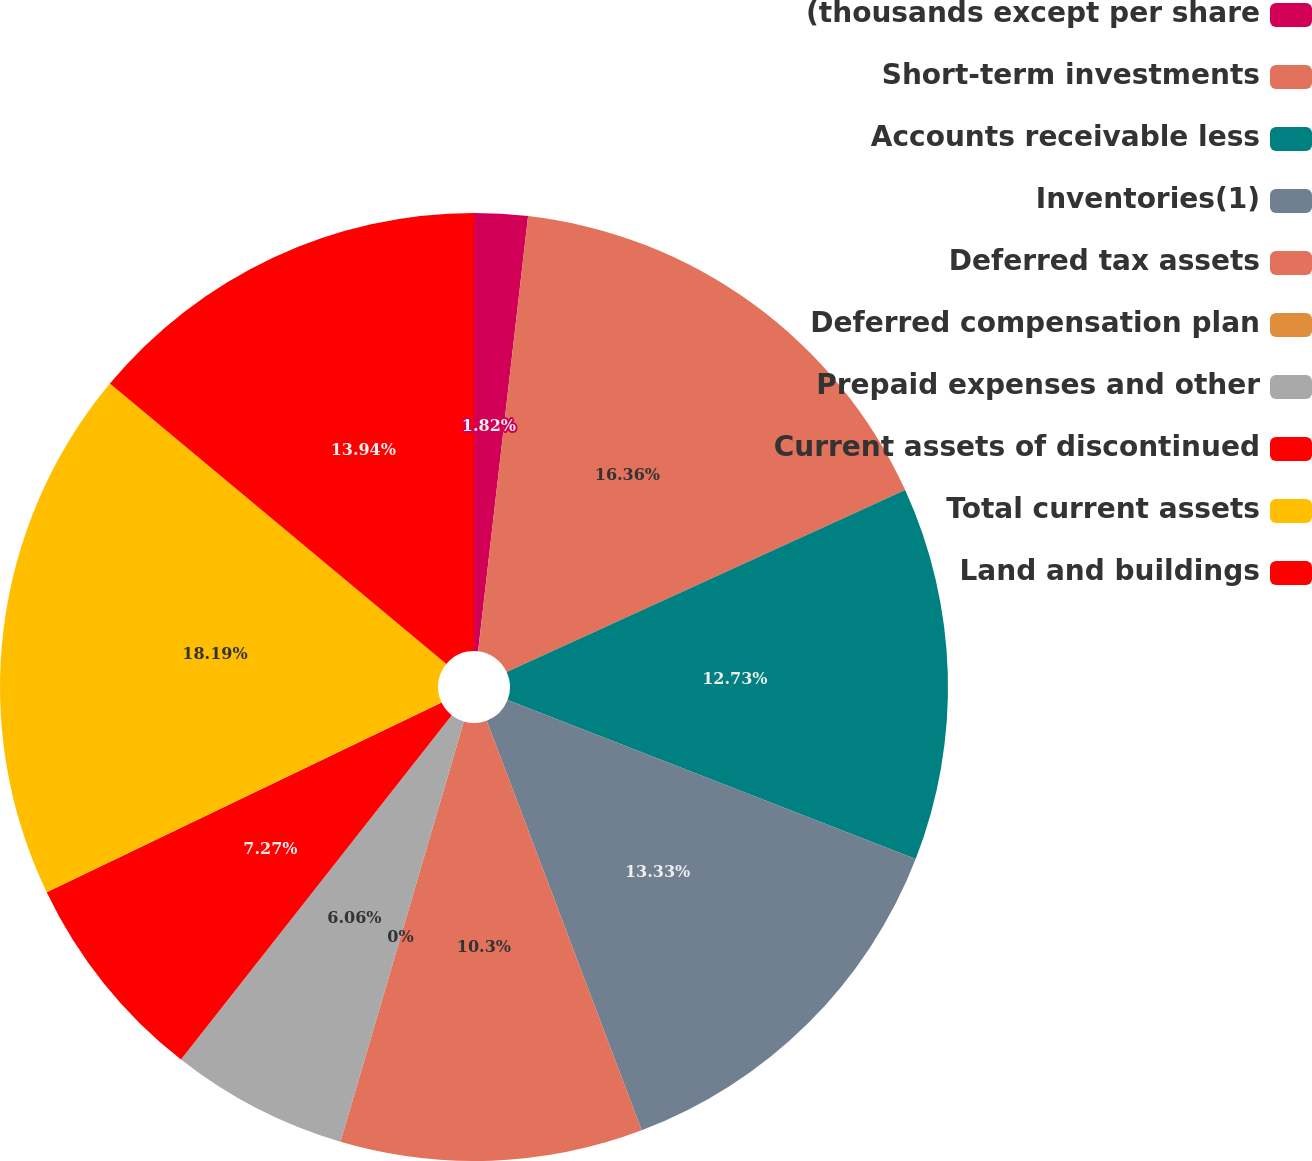<chart> <loc_0><loc_0><loc_500><loc_500><pie_chart><fcel>(thousands except per share<fcel>Short-term investments<fcel>Accounts receivable less<fcel>Inventories(1)<fcel>Deferred tax assets<fcel>Deferred compensation plan<fcel>Prepaid expenses and other<fcel>Current assets of discontinued<fcel>Total current assets<fcel>Land and buildings<nl><fcel>1.82%<fcel>16.36%<fcel>12.73%<fcel>13.33%<fcel>10.3%<fcel>0.0%<fcel>6.06%<fcel>7.27%<fcel>18.18%<fcel>13.94%<nl></chart> 